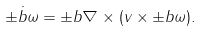<formula> <loc_0><loc_0><loc_500><loc_500>\dot { \pm b { \omega } } = { \pm b \nabla } \times ( { v } \times \pm b { \omega } ) .</formula> 